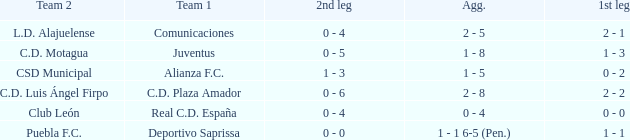What is the 2nd leg of the Comunicaciones team? 0 - 4. 